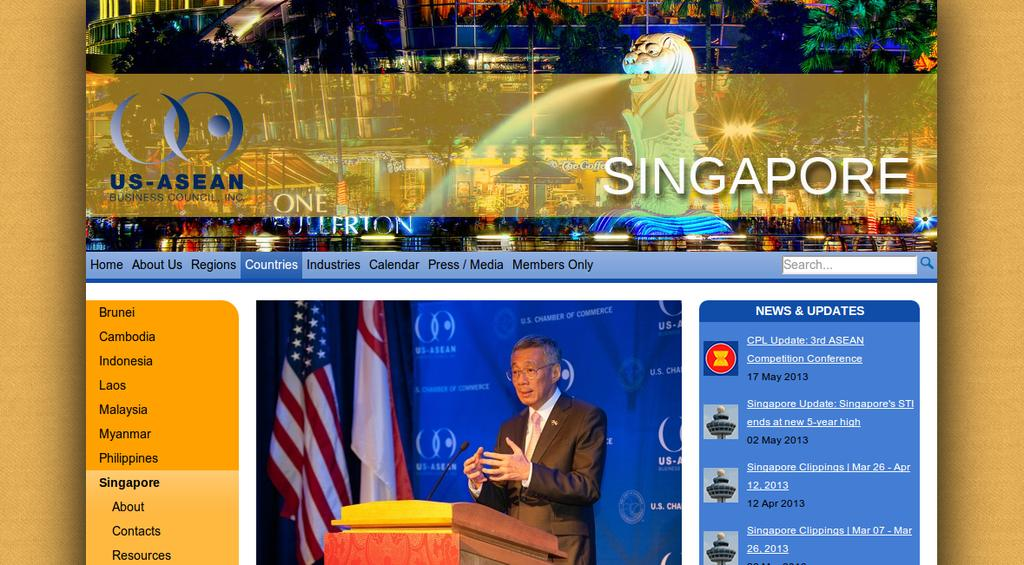<image>
Create a compact narrative representing the image presented. The top half of a poster advertising an event in Singapore. 